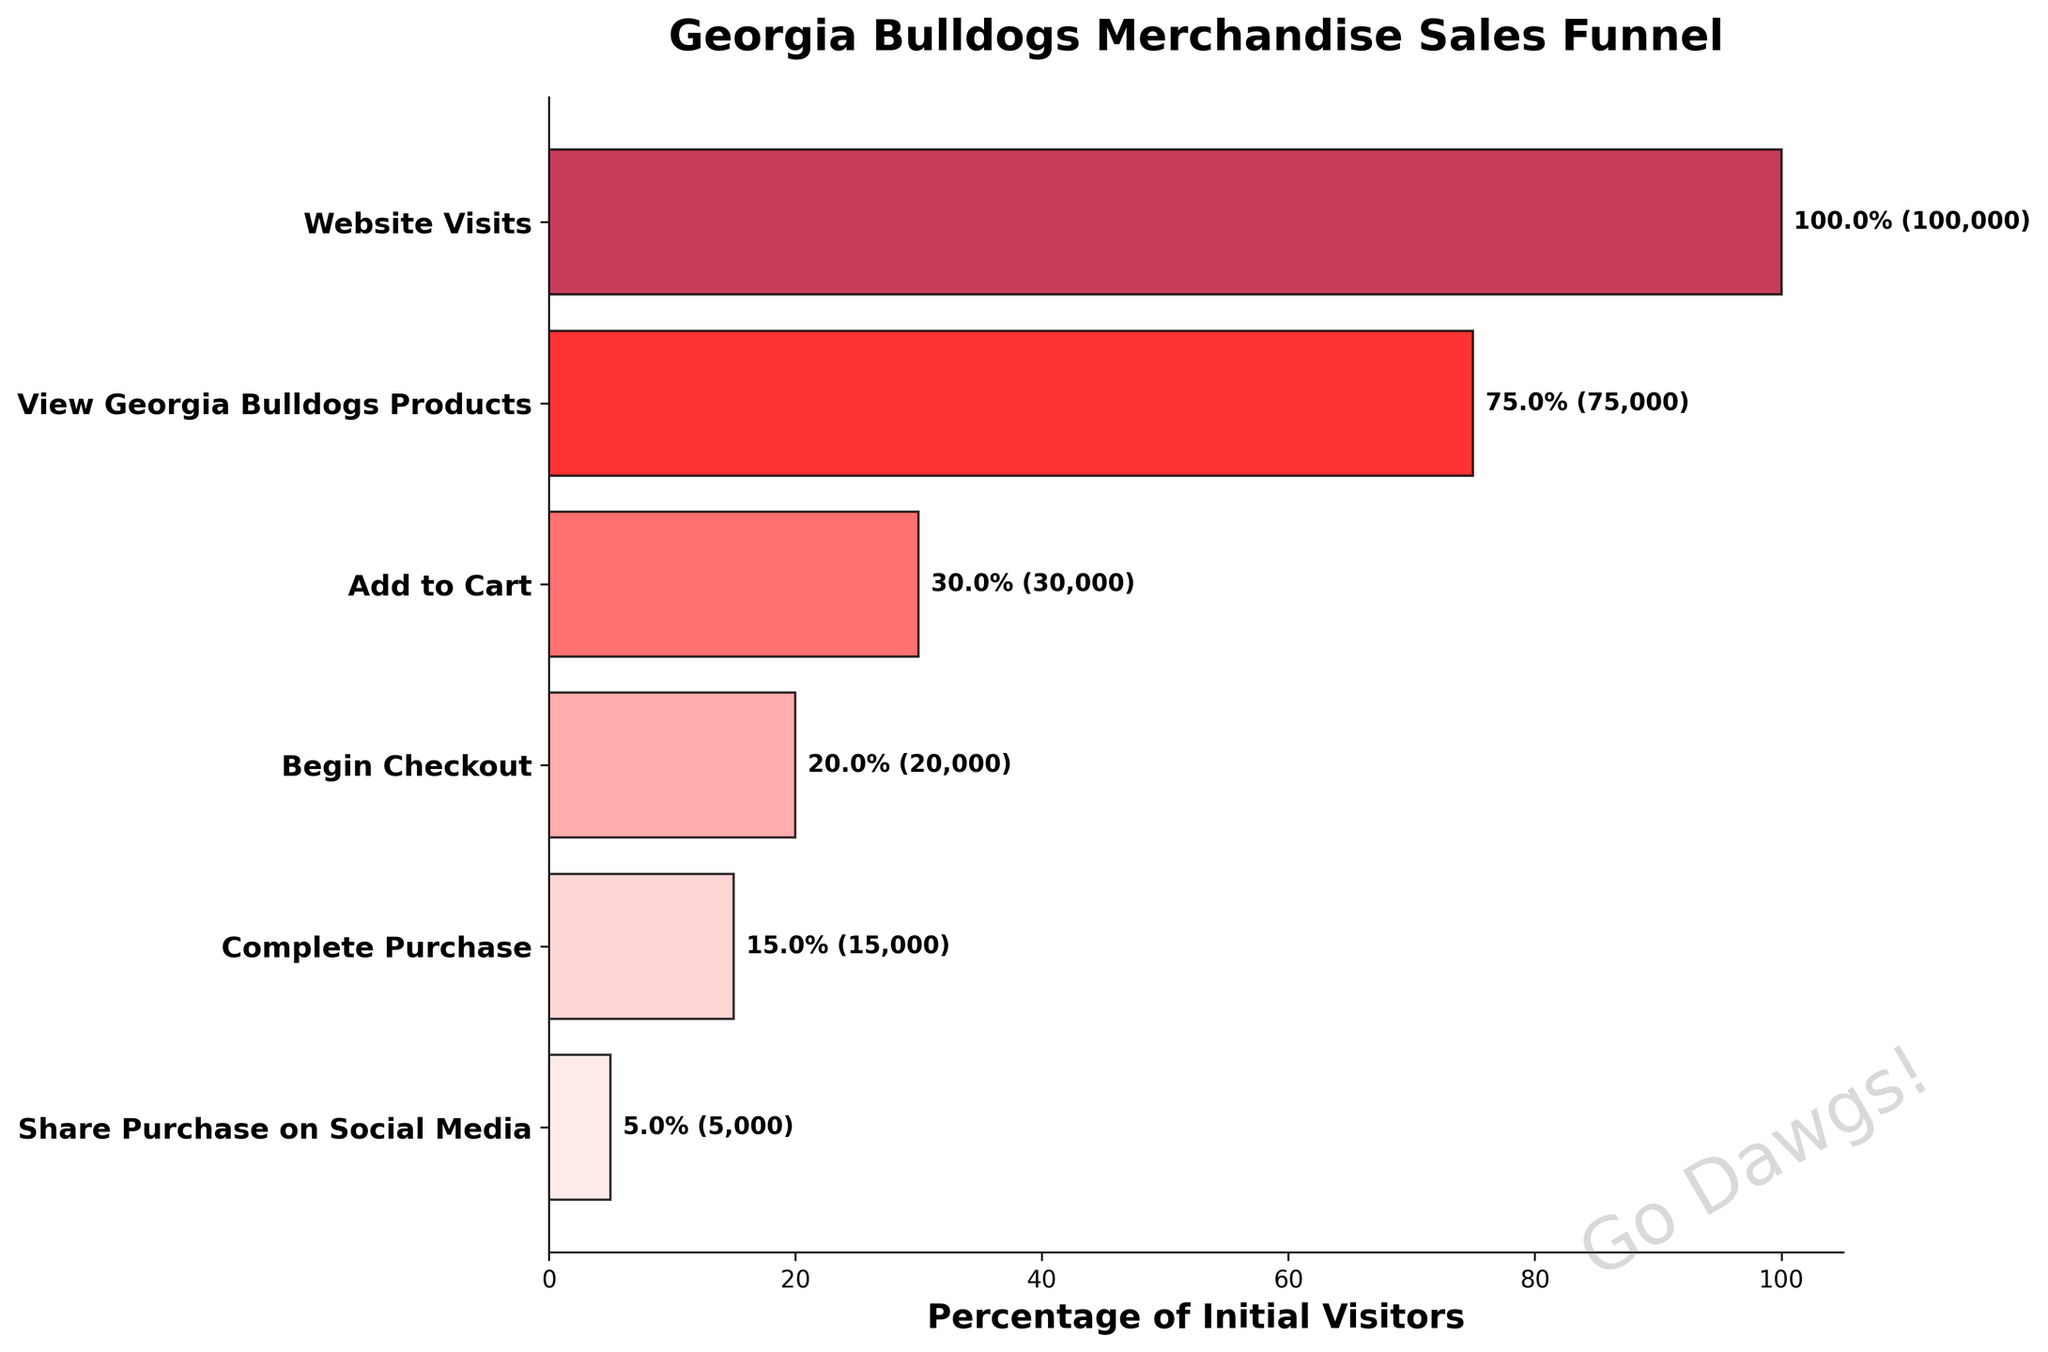Which stage has the highest number of users? The stage with the highest number of users is the first one, "Website Visits," as it is the entry point of the funnel.
Answer: Website Visits How many users completed a purchase? From the percentage labels and user counts, we see that 15,000 users completed a purchase.
Answer: 15,000 What is the percentage of users who added a product to their cart? The "Add to Cart" stage shows a bar labeled with 30.0%, indicating that 30% of the initial visitors added a product to their cart.
Answer: 30% How many users did not complete the purchase after beginning the checkout process? Subtract the "Complete Purchase" users (15,000) from the "Begin Checkout" users (20,000): 20,000 - 15,000 = 5,000.
Answer: 5,000 Which stage has the lowest conversion rate from the previous stage? The "Share Purchase on Social Media" stage has the lowest conversion rate, dropping from 15,000 users completing the purchase to 5,000 users sharing it on social media.
Answer: Share Purchase on Social Media What is the total drop-off from the initial website visits to adding a product to the cart? Subtract the "Add to Cart" users (30,000) from the "Website Visits" users (100,000): 100,000 - 30,000 = 70,000.
Answer: 70,000 Which stage has the highest percentage drop-off relative to the previous stage? Calculate the percentage drop between stages and identify the highest: the drop from "Begin Checkout" (20%) to "Complete Purchase" (15%) results in a 25% drop, which is the highest.
Answer: From Begin Checkout to Complete Purchase What percentage of users who added products to their cart actually completed a purchase? Divide "Complete Purchase" users (15,000) by "Add to Cart" users (30,000) and multiply by 100: (15,000 / 30,000) * 100 = 50%.
Answer: 50% What is the title of the funnel chart? The title of the funnel chart is displayed at the top and reads "Georgia Bulldogs Merchandise Sales Funnel."
Answer: Georgia Bulldogs Merchandise Sales Funnel 